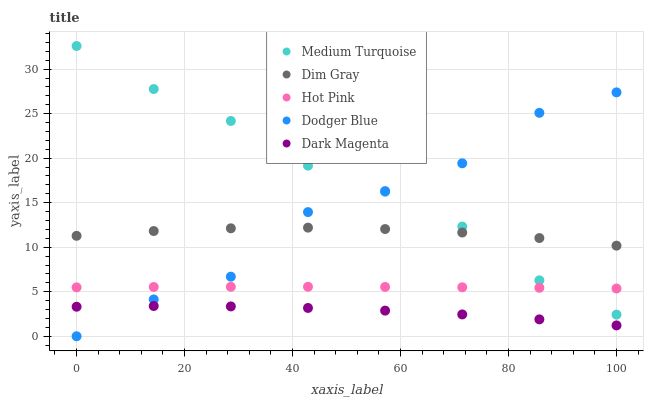Does Dark Magenta have the minimum area under the curve?
Answer yes or no. Yes. Does Medium Turquoise have the maximum area under the curve?
Answer yes or no. Yes. Does Dodger Blue have the minimum area under the curve?
Answer yes or no. No. Does Dodger Blue have the maximum area under the curve?
Answer yes or no. No. Is Hot Pink the smoothest?
Answer yes or no. Yes. Is Dodger Blue the roughest?
Answer yes or no. Yes. Is Dark Magenta the smoothest?
Answer yes or no. No. Is Dark Magenta the roughest?
Answer yes or no. No. Does Dodger Blue have the lowest value?
Answer yes or no. Yes. Does Dark Magenta have the lowest value?
Answer yes or no. No. Does Medium Turquoise have the highest value?
Answer yes or no. Yes. Does Dodger Blue have the highest value?
Answer yes or no. No. Is Dark Magenta less than Dim Gray?
Answer yes or no. Yes. Is Dim Gray greater than Hot Pink?
Answer yes or no. Yes. Does Hot Pink intersect Dodger Blue?
Answer yes or no. Yes. Is Hot Pink less than Dodger Blue?
Answer yes or no. No. Is Hot Pink greater than Dodger Blue?
Answer yes or no. No. Does Dark Magenta intersect Dim Gray?
Answer yes or no. No. 